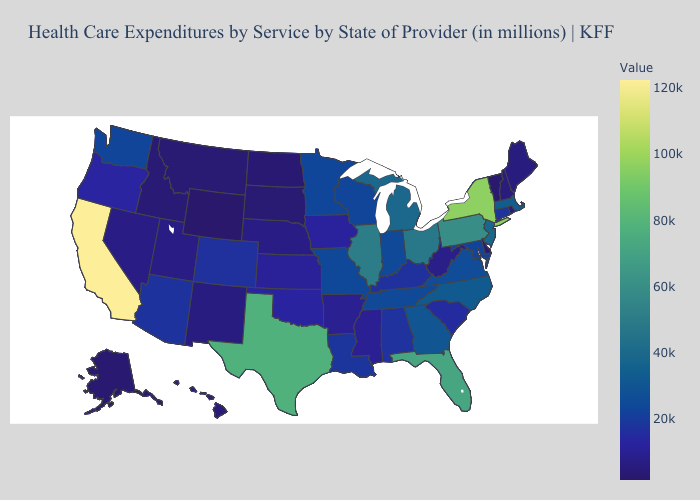Does the map have missing data?
Concise answer only. No. Is the legend a continuous bar?
Write a very short answer. Yes. Is the legend a continuous bar?
Answer briefly. Yes. 